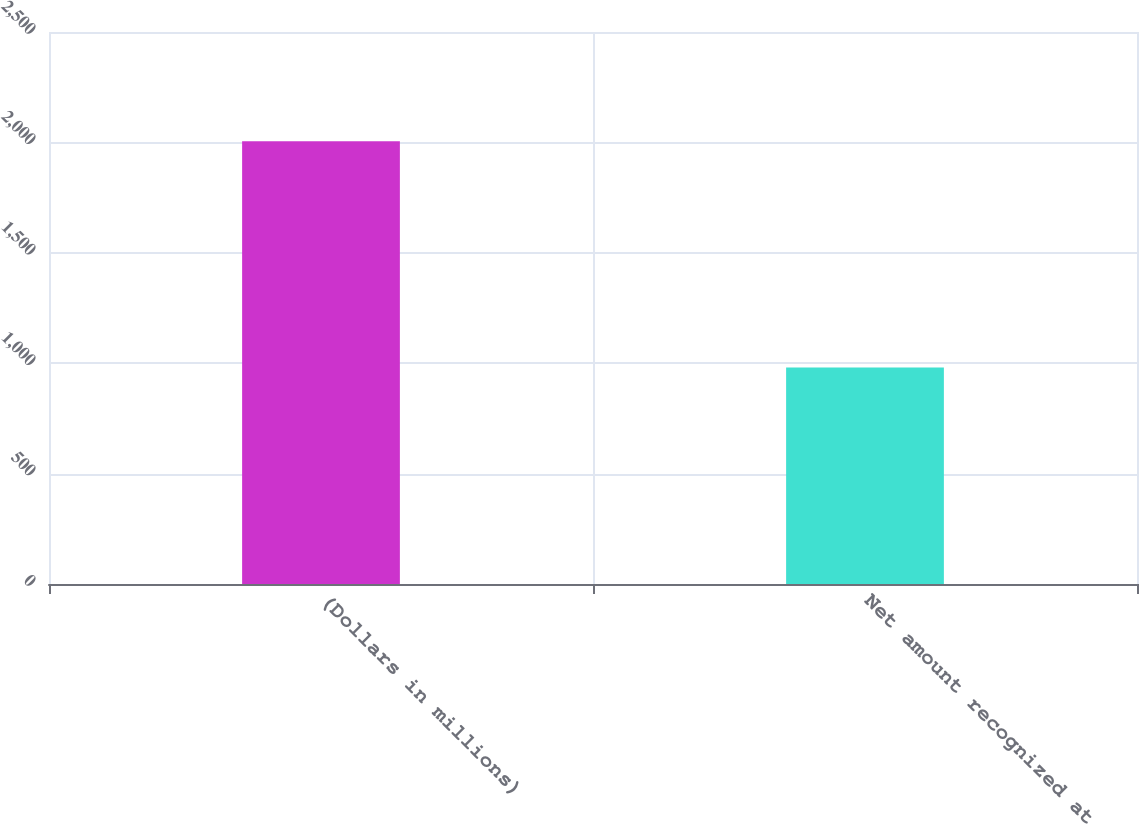Convert chart. <chart><loc_0><loc_0><loc_500><loc_500><bar_chart><fcel>(Dollars in millions)<fcel>Net amount recognized at<nl><fcel>2005<fcel>981<nl></chart> 